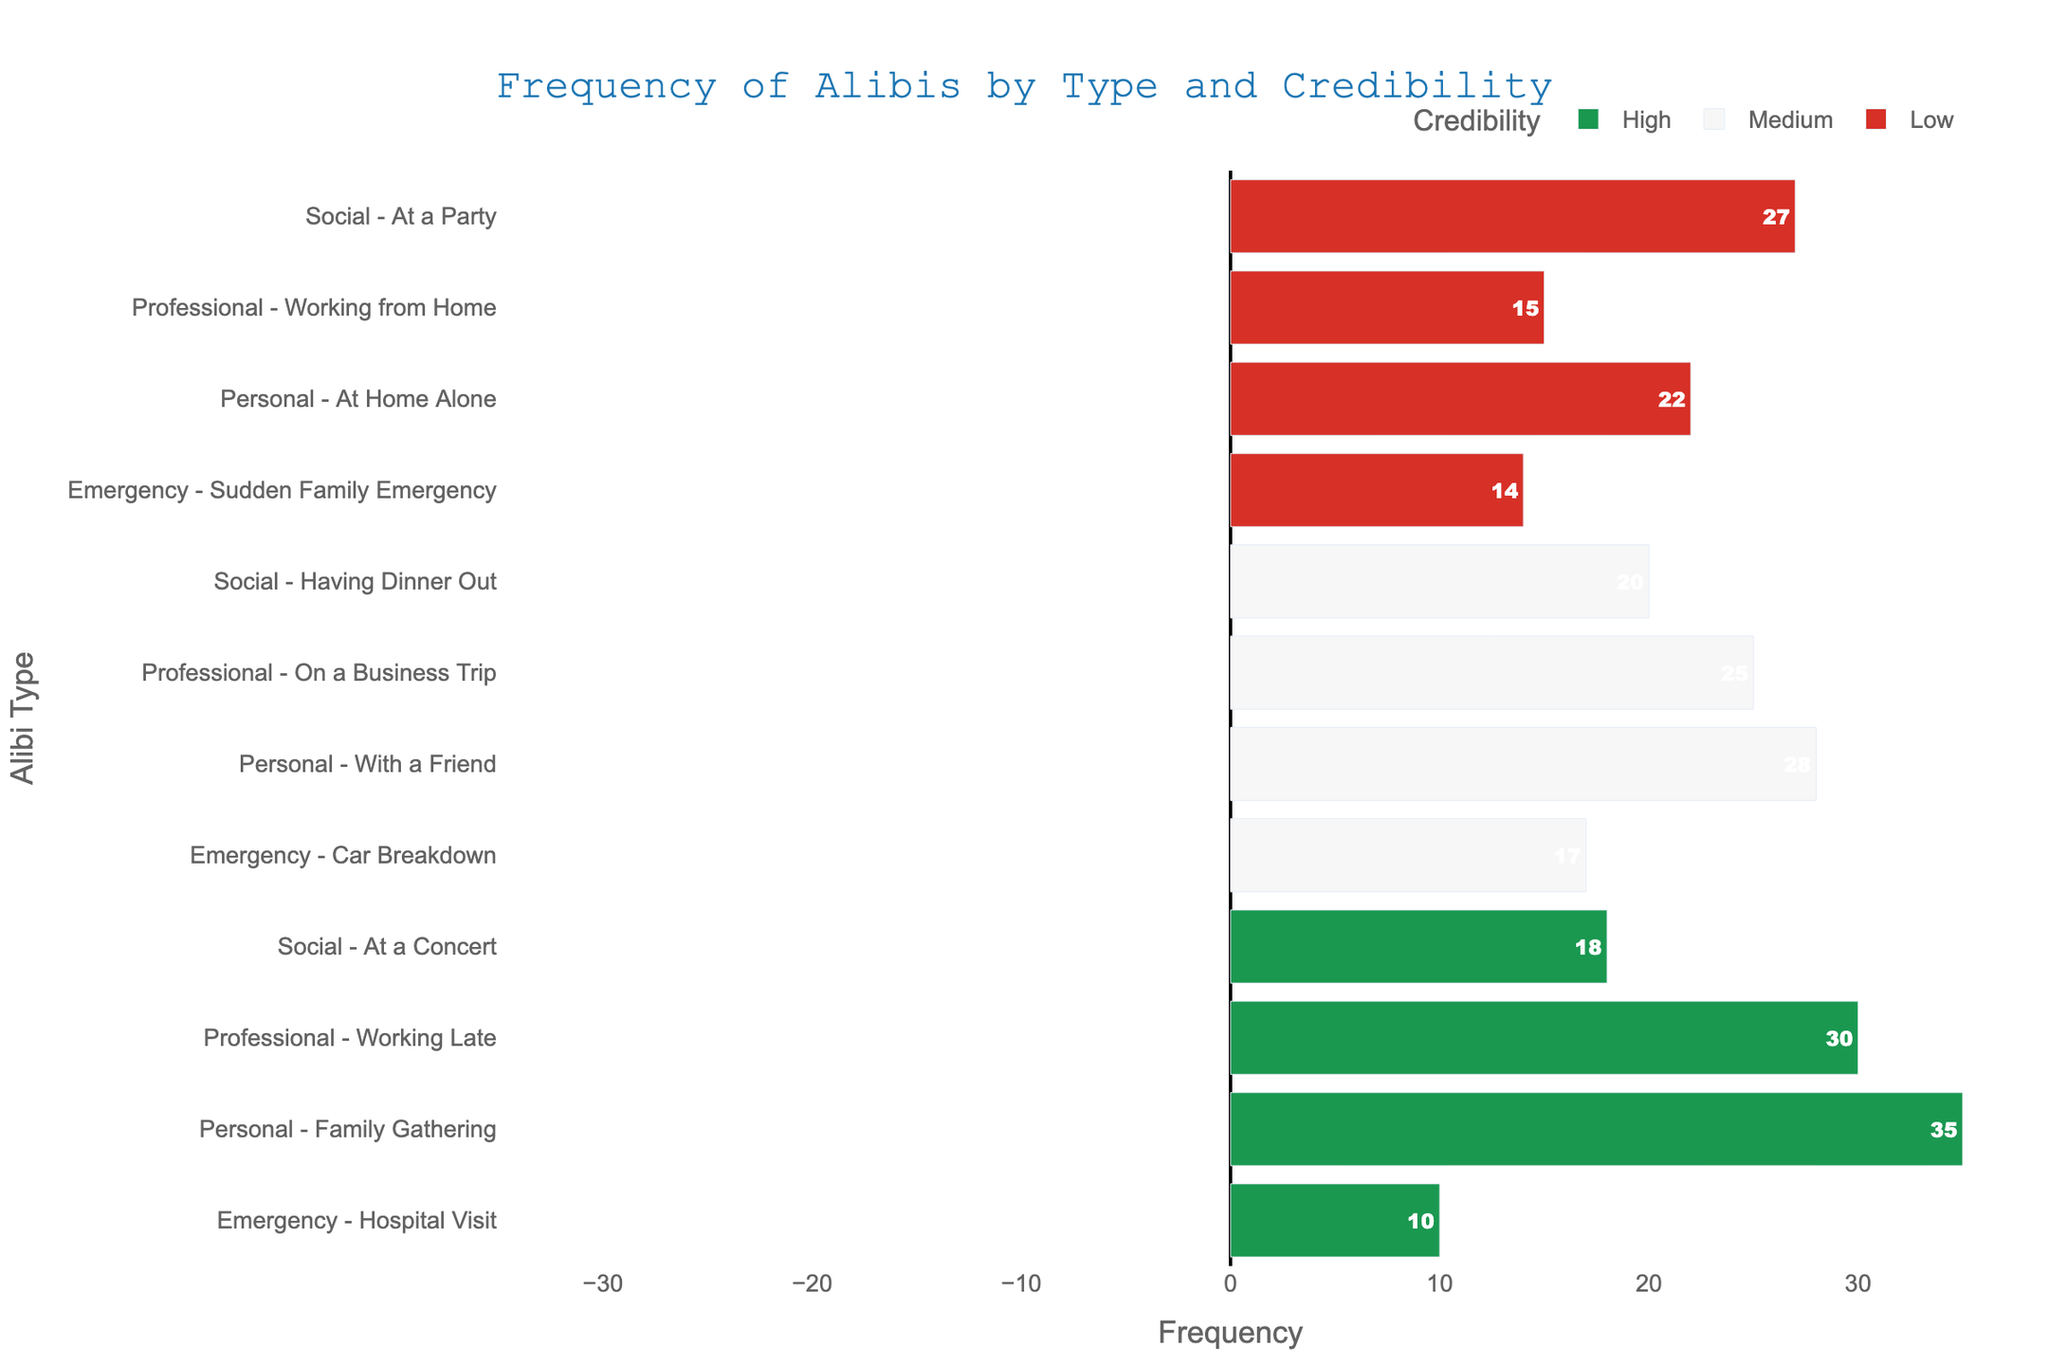Which alibi has the highest frequency and what is its credibility? To find the alibi with the highest frequency, we look at the length of the bars. "Family Gathering" under "Personal" type has the longest bar. Its frequency is 35 and its credibility is High.
Answer: Family Gathering, High Which alibi has the lowest frequency and what is its credibility? To find the alibi with the lowest frequency, we look for the shortest bar. "Hospital Visit" under "Emergency" type has the shortest bar. Its frequency is 10 and its credibility is High.
Answer: Hospital Visit, High Compare the frequencies of alibis with high credibility. What is the difference between the alibi with the highest frequency and the alibi with the lowest frequency? Alibis with high credibility are "Family Gathering" (35), "Working Late" (30), "At a Concert" (18), and "Hospital Visit" (10). The difference between Family Gathering (highest) and Hospital Visit (lowest) is 35 - 10 = 25.
Answer: 25 Which type has the most total frequency across all credibility levels? For "Personal": 35 (High) + 22 (Low) + 28 (Medium) = 85, for "Professional": 30 (High) + 25 (Medium) + 15 (Low) = 70, for "Social": 18 (High) + 20 (Medium) + 27 (Low) = 65, for "Emergency": 10 (High) + 17 (Medium) + 14 (Low) = 41. The type with the highest total frequency is "Personal".
Answer: Personal How many more times was "Working Late" given as an alibi compared to "Working from Home"? "Working Late" has a frequency of 30 (High), and "Working from Home" has a frequency of 15 (Low). The difference is 30 - 15 = 15.
Answer: 15 What is the average frequency of all Medium credibility alibis? Medium credibility alibis are "With a Friend" (28), "On a Business Trip" (25), "Having Dinner Out" (20), and "Car Breakdown" (17). Their average frequency is (28 + 25 + 20 + 17) / 4 = 22.5.
Answer: 22.5 